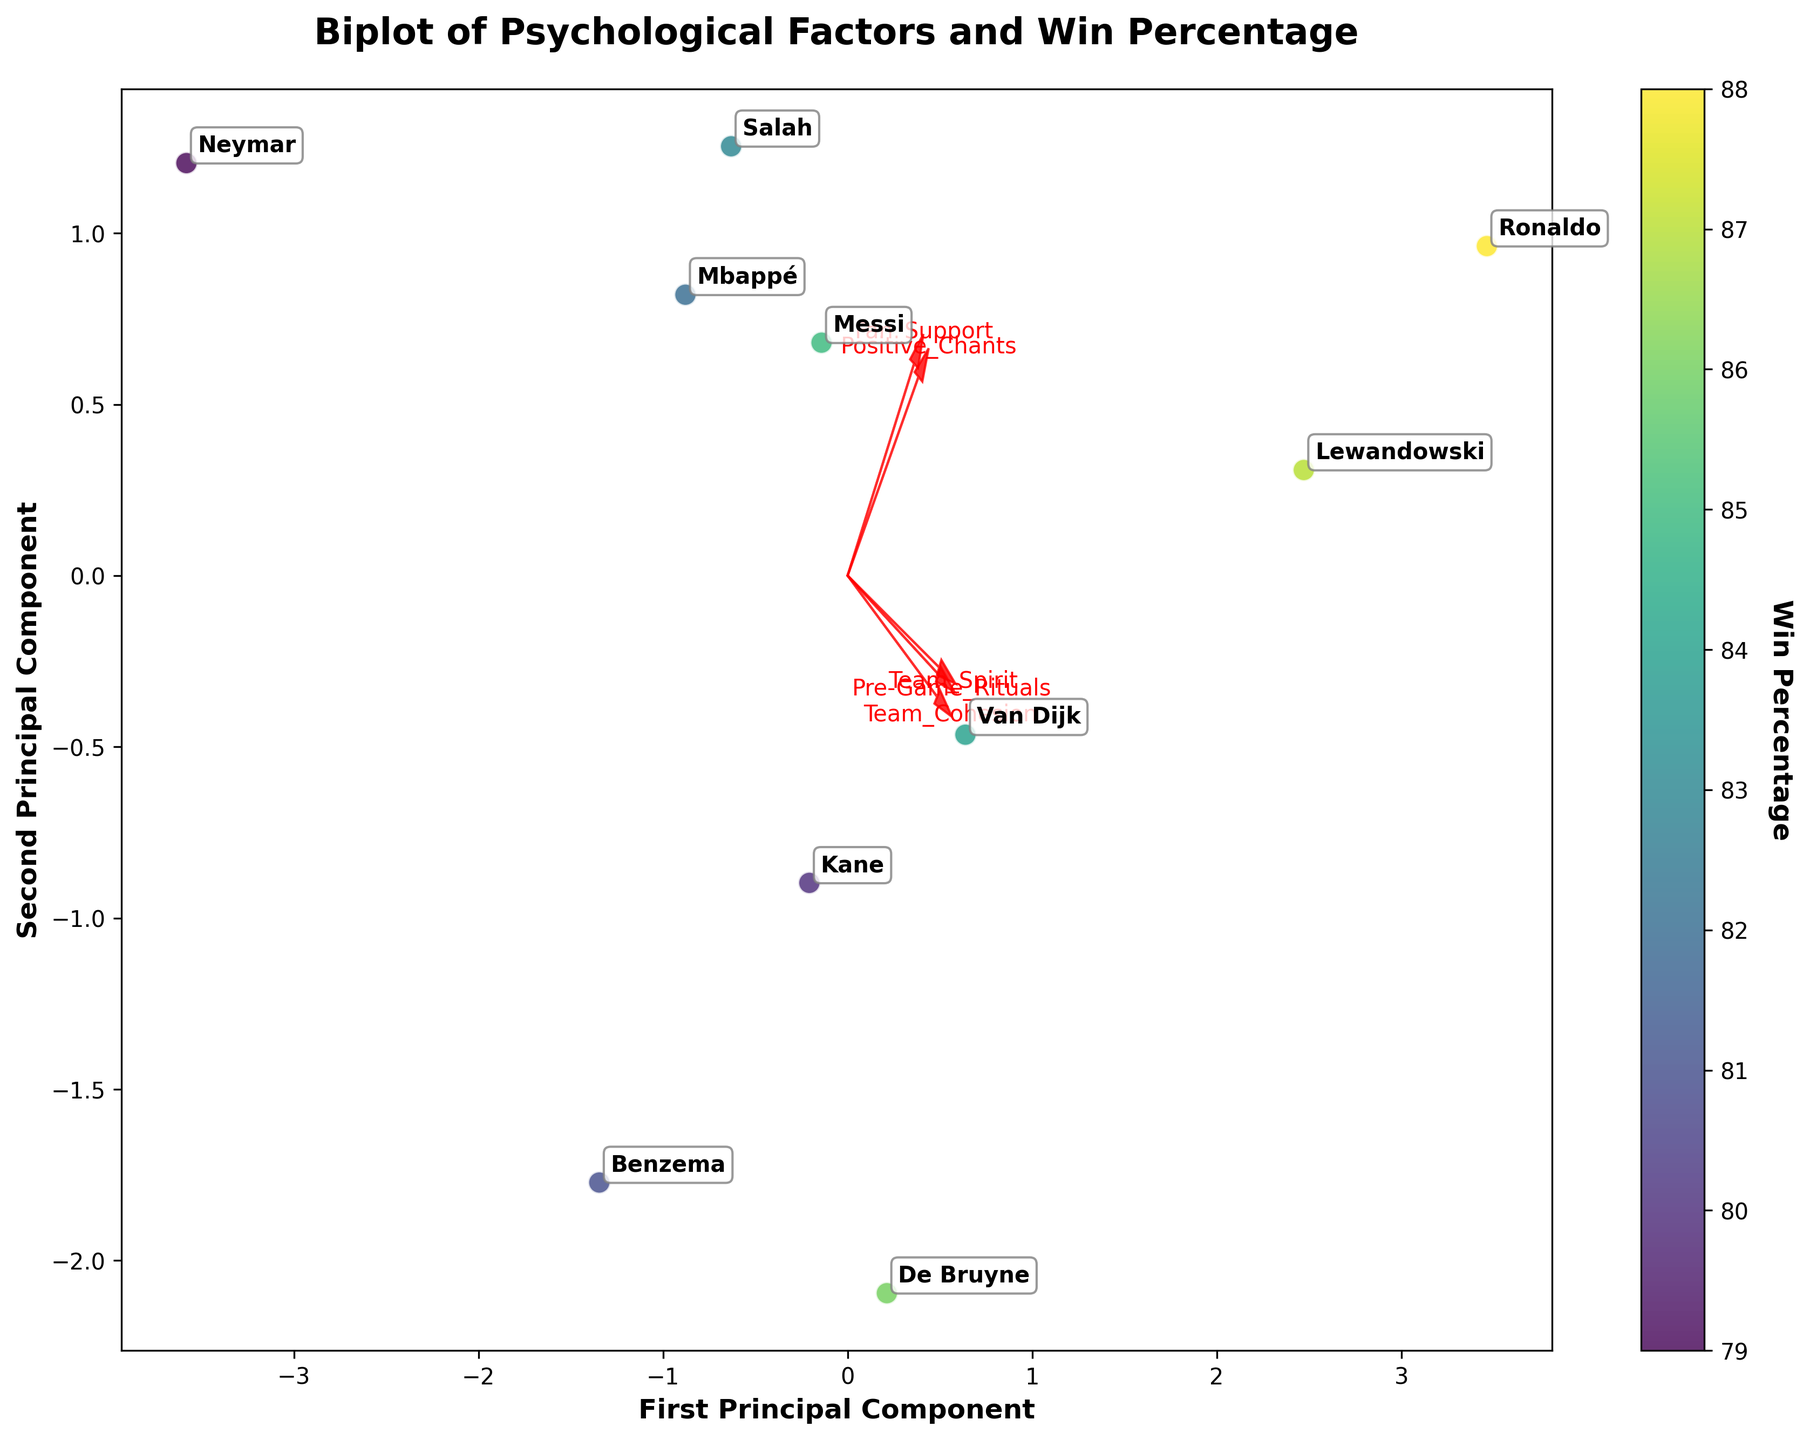What psychological factor has the strongest influence on the first principal component (PC1)? By looking at the length and direction of the feature vectors along the first principal component axis, we can see that the arrow representing "Team_Spirit" extends the farthest along PC1. This suggests that "Team_Spirit" has the strongest influence on PC1.
Answer: Team Spirit Which player's score is closest to the origin in the biplot? The player's score closest to the origin of the biplot can be identified by looking at the player's name that falls nearest to the center (where both PC1 and PC2 are zero). This position is closest for "Benzema".
Answer: Benzema How many psychological factors are represented in the biplot? The plot shows arrows indicating different psychological factors. Counting these arrows gives the number of factors represented. There are 5 arrows with labels indicating the factors.
Answer: 5 Which two psychological factors are most correlated with each other? Correlation between psychological factors can be inferred from the angles between their arrows. Smaller angles indicate higher positive correlation. The arrows for "Fan_Support" and "Positive_Chants" are nearly parallel, suggesting high correlation.
Answer: Fan Support and Positive Chants Who has the highest Win Percentage among the players represented in the biplot? The color intensity of the scatter points indicates Win Percentage. The player annotated at the point with the most intense yellow color has the highest Win Percentage. This corresponds to "Ronaldo".
Answer: Ronaldo Which player is strongly associated with high Team Cohesion but moderate Pre-Game Rituals? The player's association with high Team Cohesion can be found near the direction of the "Team_Cohesion" vector but away from the "Pre-Game_Rituals" vector. "Lewandowski" is positioned in such a way in the biplot.
Answer: Lewandowski What does the color of the scatter points represent in the biplot? Observing the color scale (colorbar) associated with the scatter points, it represents Win Percentage.
Answer: Win Percentage 